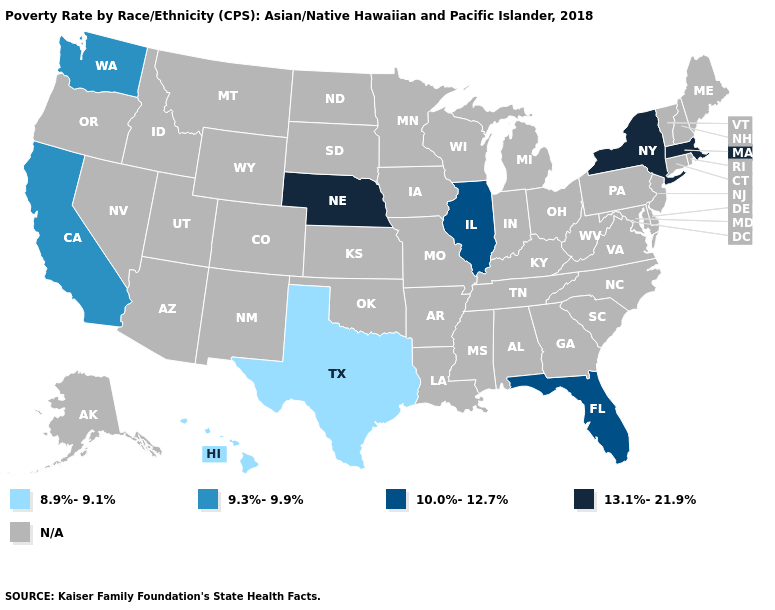What is the value of Iowa?
Answer briefly. N/A. Name the states that have a value in the range 10.0%-12.7%?
Short answer required. Florida, Illinois. Does California have the highest value in the USA?
Concise answer only. No. Name the states that have a value in the range 9.3%-9.9%?
Quick response, please. California, Washington. Name the states that have a value in the range 9.3%-9.9%?
Concise answer only. California, Washington. Is the legend a continuous bar?
Concise answer only. No. Name the states that have a value in the range 9.3%-9.9%?
Answer briefly. California, Washington. What is the value of Connecticut?
Answer briefly. N/A. 